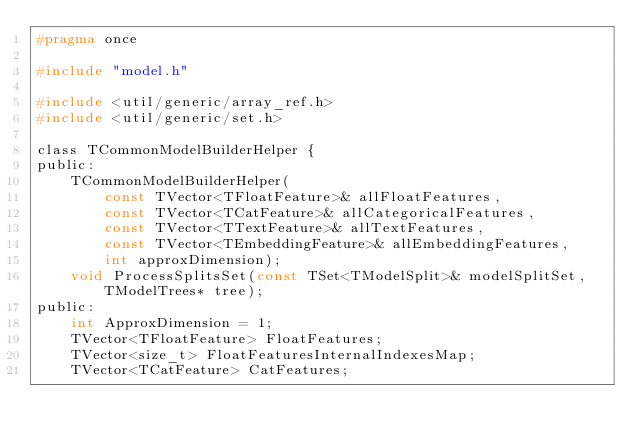Convert code to text. <code><loc_0><loc_0><loc_500><loc_500><_C_>#pragma once

#include "model.h"

#include <util/generic/array_ref.h>
#include <util/generic/set.h>

class TCommonModelBuilderHelper {
public:
    TCommonModelBuilderHelper(
        const TVector<TFloatFeature>& allFloatFeatures,
        const TVector<TCatFeature>& allCategoricalFeatures,
        const TVector<TTextFeature>& allTextFeatures,
        const TVector<TEmbeddingFeature>& allEmbeddingFeatures,
        int approxDimension);
    void ProcessSplitsSet(const TSet<TModelSplit>& modelSplitSet, TModelTrees* tree);
public:
    int ApproxDimension = 1;
    TVector<TFloatFeature> FloatFeatures;
    TVector<size_t> FloatFeaturesInternalIndexesMap;
    TVector<TCatFeature> CatFeatures;</code> 